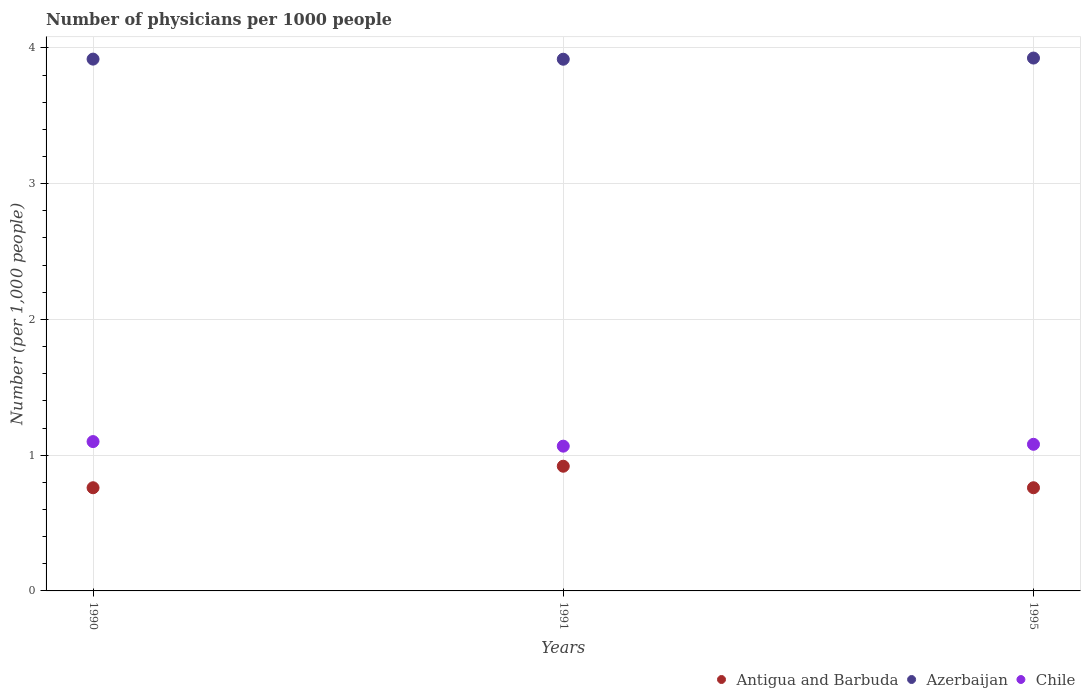How many different coloured dotlines are there?
Provide a short and direct response. 3. Is the number of dotlines equal to the number of legend labels?
Your answer should be compact. Yes. What is the number of physicians in Chile in 1990?
Make the answer very short. 1.1. Across all years, what is the maximum number of physicians in Chile?
Make the answer very short. 1.1. Across all years, what is the minimum number of physicians in Chile?
Provide a succinct answer. 1.07. What is the total number of physicians in Antigua and Barbuda in the graph?
Make the answer very short. 2.44. What is the difference between the number of physicians in Chile in 1991 and that in 1995?
Ensure brevity in your answer.  -0.01. What is the difference between the number of physicians in Antigua and Barbuda in 1991 and the number of physicians in Chile in 1995?
Provide a succinct answer. -0.16. What is the average number of physicians in Azerbaijan per year?
Your response must be concise. 3.92. In the year 1990, what is the difference between the number of physicians in Chile and number of physicians in Antigua and Barbuda?
Ensure brevity in your answer.  0.34. In how many years, is the number of physicians in Azerbaijan greater than 0.8?
Offer a terse response. 3. What is the ratio of the number of physicians in Azerbaijan in 1991 to that in 1995?
Ensure brevity in your answer.  1. Is the difference between the number of physicians in Chile in 1990 and 1991 greater than the difference between the number of physicians in Antigua and Barbuda in 1990 and 1991?
Keep it short and to the point. Yes. What is the difference between the highest and the second highest number of physicians in Chile?
Your answer should be compact. 0.02. What is the difference between the highest and the lowest number of physicians in Antigua and Barbuda?
Offer a terse response. 0.16. Is it the case that in every year, the sum of the number of physicians in Azerbaijan and number of physicians in Antigua and Barbuda  is greater than the number of physicians in Chile?
Give a very brief answer. Yes. Is the number of physicians in Antigua and Barbuda strictly greater than the number of physicians in Azerbaijan over the years?
Offer a very short reply. No. Is the number of physicians in Antigua and Barbuda strictly less than the number of physicians in Chile over the years?
Make the answer very short. Yes. How many dotlines are there?
Make the answer very short. 3. How many years are there in the graph?
Keep it short and to the point. 3. What is the difference between two consecutive major ticks on the Y-axis?
Ensure brevity in your answer.  1. Does the graph contain any zero values?
Provide a short and direct response. No. Does the graph contain grids?
Give a very brief answer. Yes. How are the legend labels stacked?
Your answer should be compact. Horizontal. What is the title of the graph?
Your answer should be very brief. Number of physicians per 1000 people. What is the label or title of the X-axis?
Your answer should be very brief. Years. What is the label or title of the Y-axis?
Make the answer very short. Number (per 1,0 people). What is the Number (per 1,000 people) of Antigua and Barbuda in 1990?
Make the answer very short. 0.76. What is the Number (per 1,000 people) of Azerbaijan in 1990?
Make the answer very short. 3.92. What is the Number (per 1,000 people) in Chile in 1990?
Keep it short and to the point. 1.1. What is the Number (per 1,000 people) of Antigua and Barbuda in 1991?
Offer a terse response. 0.92. What is the Number (per 1,000 people) of Azerbaijan in 1991?
Offer a very short reply. 3.92. What is the Number (per 1,000 people) of Chile in 1991?
Your response must be concise. 1.07. What is the Number (per 1,000 people) of Antigua and Barbuda in 1995?
Your response must be concise. 0.76. What is the Number (per 1,000 people) of Azerbaijan in 1995?
Keep it short and to the point. 3.92. Across all years, what is the maximum Number (per 1,000 people) in Antigua and Barbuda?
Your answer should be compact. 0.92. Across all years, what is the maximum Number (per 1,000 people) of Azerbaijan?
Provide a succinct answer. 3.92. Across all years, what is the maximum Number (per 1,000 people) in Chile?
Keep it short and to the point. 1.1. Across all years, what is the minimum Number (per 1,000 people) of Antigua and Barbuda?
Your answer should be very brief. 0.76. Across all years, what is the minimum Number (per 1,000 people) in Azerbaijan?
Your answer should be compact. 3.92. Across all years, what is the minimum Number (per 1,000 people) in Chile?
Keep it short and to the point. 1.07. What is the total Number (per 1,000 people) in Antigua and Barbuda in the graph?
Make the answer very short. 2.44. What is the total Number (per 1,000 people) of Azerbaijan in the graph?
Give a very brief answer. 11.76. What is the total Number (per 1,000 people) of Chile in the graph?
Offer a terse response. 3.25. What is the difference between the Number (per 1,000 people) of Antigua and Barbuda in 1990 and that in 1991?
Your answer should be compact. -0.16. What is the difference between the Number (per 1,000 people) of Azerbaijan in 1990 and that in 1991?
Provide a succinct answer. 0. What is the difference between the Number (per 1,000 people) in Chile in 1990 and that in 1991?
Offer a terse response. 0.03. What is the difference between the Number (per 1,000 people) in Azerbaijan in 1990 and that in 1995?
Provide a short and direct response. -0.01. What is the difference between the Number (per 1,000 people) in Antigua and Barbuda in 1991 and that in 1995?
Offer a very short reply. 0.16. What is the difference between the Number (per 1,000 people) in Azerbaijan in 1991 and that in 1995?
Make the answer very short. -0.01. What is the difference between the Number (per 1,000 people) of Chile in 1991 and that in 1995?
Give a very brief answer. -0.01. What is the difference between the Number (per 1,000 people) in Antigua and Barbuda in 1990 and the Number (per 1,000 people) in Azerbaijan in 1991?
Your answer should be compact. -3.16. What is the difference between the Number (per 1,000 people) in Antigua and Barbuda in 1990 and the Number (per 1,000 people) in Chile in 1991?
Offer a very short reply. -0.31. What is the difference between the Number (per 1,000 people) of Azerbaijan in 1990 and the Number (per 1,000 people) of Chile in 1991?
Give a very brief answer. 2.85. What is the difference between the Number (per 1,000 people) of Antigua and Barbuda in 1990 and the Number (per 1,000 people) of Azerbaijan in 1995?
Give a very brief answer. -3.17. What is the difference between the Number (per 1,000 people) in Antigua and Barbuda in 1990 and the Number (per 1,000 people) in Chile in 1995?
Keep it short and to the point. -0.32. What is the difference between the Number (per 1,000 people) in Azerbaijan in 1990 and the Number (per 1,000 people) in Chile in 1995?
Provide a succinct answer. 2.84. What is the difference between the Number (per 1,000 people) of Antigua and Barbuda in 1991 and the Number (per 1,000 people) of Azerbaijan in 1995?
Ensure brevity in your answer.  -3.01. What is the difference between the Number (per 1,000 people) in Antigua and Barbuda in 1991 and the Number (per 1,000 people) in Chile in 1995?
Ensure brevity in your answer.  -0.16. What is the difference between the Number (per 1,000 people) in Azerbaijan in 1991 and the Number (per 1,000 people) in Chile in 1995?
Make the answer very short. 2.84. What is the average Number (per 1,000 people) in Antigua and Barbuda per year?
Your answer should be compact. 0.81. What is the average Number (per 1,000 people) in Azerbaijan per year?
Provide a short and direct response. 3.92. What is the average Number (per 1,000 people) in Chile per year?
Provide a short and direct response. 1.08. In the year 1990, what is the difference between the Number (per 1,000 people) of Antigua and Barbuda and Number (per 1,000 people) of Azerbaijan?
Offer a very short reply. -3.16. In the year 1990, what is the difference between the Number (per 1,000 people) in Antigua and Barbuda and Number (per 1,000 people) in Chile?
Your response must be concise. -0.34. In the year 1990, what is the difference between the Number (per 1,000 people) in Azerbaijan and Number (per 1,000 people) in Chile?
Provide a short and direct response. 2.82. In the year 1991, what is the difference between the Number (per 1,000 people) in Antigua and Barbuda and Number (per 1,000 people) in Azerbaijan?
Make the answer very short. -3. In the year 1991, what is the difference between the Number (per 1,000 people) in Antigua and Barbuda and Number (per 1,000 people) in Chile?
Keep it short and to the point. -0.15. In the year 1991, what is the difference between the Number (per 1,000 people) of Azerbaijan and Number (per 1,000 people) of Chile?
Give a very brief answer. 2.85. In the year 1995, what is the difference between the Number (per 1,000 people) in Antigua and Barbuda and Number (per 1,000 people) in Azerbaijan?
Provide a succinct answer. -3.17. In the year 1995, what is the difference between the Number (per 1,000 people) of Antigua and Barbuda and Number (per 1,000 people) of Chile?
Your answer should be compact. -0.32. In the year 1995, what is the difference between the Number (per 1,000 people) in Azerbaijan and Number (per 1,000 people) in Chile?
Make the answer very short. 2.85. What is the ratio of the Number (per 1,000 people) of Antigua and Barbuda in 1990 to that in 1991?
Your answer should be compact. 0.83. What is the ratio of the Number (per 1,000 people) of Azerbaijan in 1990 to that in 1991?
Offer a very short reply. 1. What is the ratio of the Number (per 1,000 people) of Chile in 1990 to that in 1991?
Your response must be concise. 1.03. What is the ratio of the Number (per 1,000 people) in Chile in 1990 to that in 1995?
Ensure brevity in your answer.  1.02. What is the ratio of the Number (per 1,000 people) in Antigua and Barbuda in 1991 to that in 1995?
Your answer should be compact. 1.21. What is the ratio of the Number (per 1,000 people) of Azerbaijan in 1991 to that in 1995?
Make the answer very short. 1. What is the ratio of the Number (per 1,000 people) of Chile in 1991 to that in 1995?
Your answer should be very brief. 0.99. What is the difference between the highest and the second highest Number (per 1,000 people) of Antigua and Barbuda?
Offer a terse response. 0.16. What is the difference between the highest and the second highest Number (per 1,000 people) of Azerbaijan?
Provide a succinct answer. 0.01. What is the difference between the highest and the lowest Number (per 1,000 people) of Antigua and Barbuda?
Keep it short and to the point. 0.16. What is the difference between the highest and the lowest Number (per 1,000 people) of Azerbaijan?
Your response must be concise. 0.01. What is the difference between the highest and the lowest Number (per 1,000 people) in Chile?
Your answer should be very brief. 0.03. 